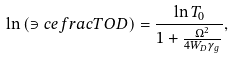<formula> <loc_0><loc_0><loc_500><loc_500>\ln { ( \ni c e f r a c { T } { O D } ) } = \frac { \ln { T _ { 0 } } } { 1 + \frac { \Omega ^ { 2 } } { 4 W _ { D } \gamma _ { g } } } ,</formula> 